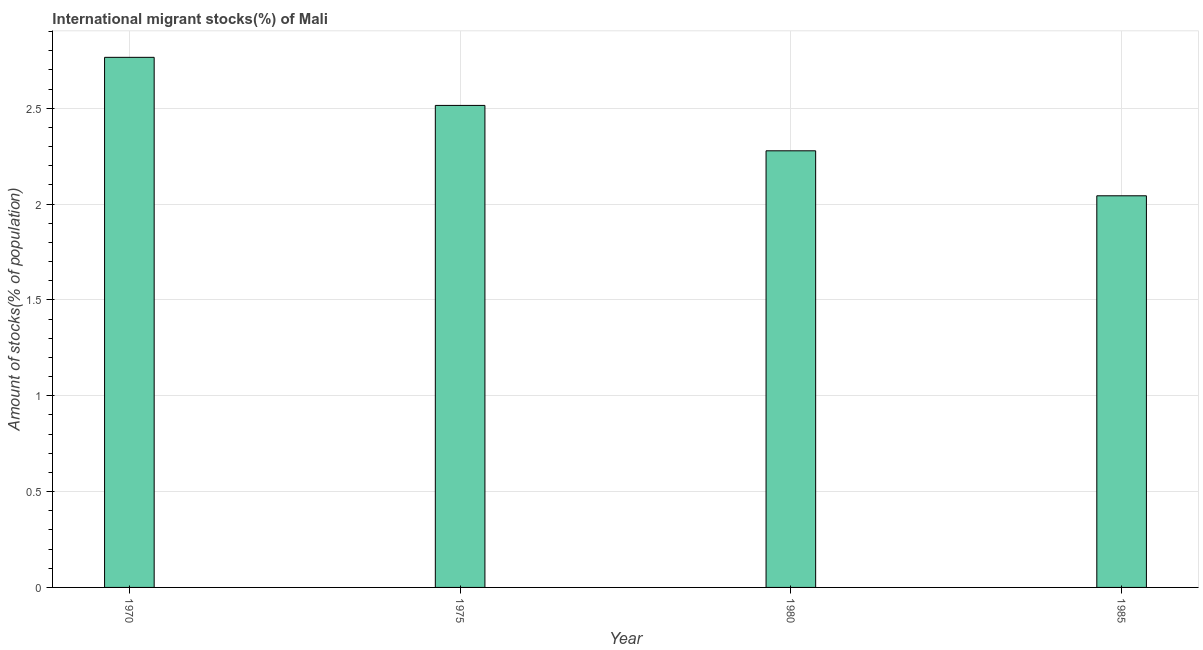Does the graph contain any zero values?
Your response must be concise. No. Does the graph contain grids?
Your answer should be very brief. Yes. What is the title of the graph?
Give a very brief answer. International migrant stocks(%) of Mali. What is the label or title of the Y-axis?
Your answer should be compact. Amount of stocks(% of population). What is the number of international migrant stocks in 1985?
Your response must be concise. 2.04. Across all years, what is the maximum number of international migrant stocks?
Ensure brevity in your answer.  2.77. Across all years, what is the minimum number of international migrant stocks?
Offer a very short reply. 2.04. In which year was the number of international migrant stocks maximum?
Make the answer very short. 1970. What is the sum of the number of international migrant stocks?
Offer a very short reply. 9.6. What is the difference between the number of international migrant stocks in 1970 and 1975?
Provide a short and direct response. 0.25. What is the average number of international migrant stocks per year?
Offer a very short reply. 2.4. What is the median number of international migrant stocks?
Your answer should be compact. 2.4. In how many years, is the number of international migrant stocks greater than 1.7 %?
Offer a very short reply. 4. Do a majority of the years between 1975 and 1985 (inclusive) have number of international migrant stocks greater than 0.7 %?
Your answer should be compact. Yes. Is the number of international migrant stocks in 1975 less than that in 1985?
Keep it short and to the point. No. Is the difference between the number of international migrant stocks in 1980 and 1985 greater than the difference between any two years?
Give a very brief answer. No. What is the difference between the highest and the second highest number of international migrant stocks?
Give a very brief answer. 0.25. Is the sum of the number of international migrant stocks in 1980 and 1985 greater than the maximum number of international migrant stocks across all years?
Offer a very short reply. Yes. What is the difference between the highest and the lowest number of international migrant stocks?
Make the answer very short. 0.72. How many years are there in the graph?
Offer a very short reply. 4. Are the values on the major ticks of Y-axis written in scientific E-notation?
Offer a very short reply. No. What is the Amount of stocks(% of population) of 1970?
Make the answer very short. 2.77. What is the Amount of stocks(% of population) of 1975?
Your answer should be very brief. 2.51. What is the Amount of stocks(% of population) in 1980?
Give a very brief answer. 2.28. What is the Amount of stocks(% of population) of 1985?
Provide a succinct answer. 2.04. What is the difference between the Amount of stocks(% of population) in 1970 and 1975?
Make the answer very short. 0.25. What is the difference between the Amount of stocks(% of population) in 1970 and 1980?
Your response must be concise. 0.49. What is the difference between the Amount of stocks(% of population) in 1970 and 1985?
Your response must be concise. 0.72. What is the difference between the Amount of stocks(% of population) in 1975 and 1980?
Provide a succinct answer. 0.24. What is the difference between the Amount of stocks(% of population) in 1975 and 1985?
Offer a very short reply. 0.47. What is the difference between the Amount of stocks(% of population) in 1980 and 1985?
Your answer should be compact. 0.23. What is the ratio of the Amount of stocks(% of population) in 1970 to that in 1975?
Provide a short and direct response. 1.1. What is the ratio of the Amount of stocks(% of population) in 1970 to that in 1980?
Make the answer very short. 1.21. What is the ratio of the Amount of stocks(% of population) in 1970 to that in 1985?
Make the answer very short. 1.35. What is the ratio of the Amount of stocks(% of population) in 1975 to that in 1980?
Your answer should be compact. 1.1. What is the ratio of the Amount of stocks(% of population) in 1975 to that in 1985?
Your answer should be compact. 1.23. What is the ratio of the Amount of stocks(% of population) in 1980 to that in 1985?
Keep it short and to the point. 1.11. 